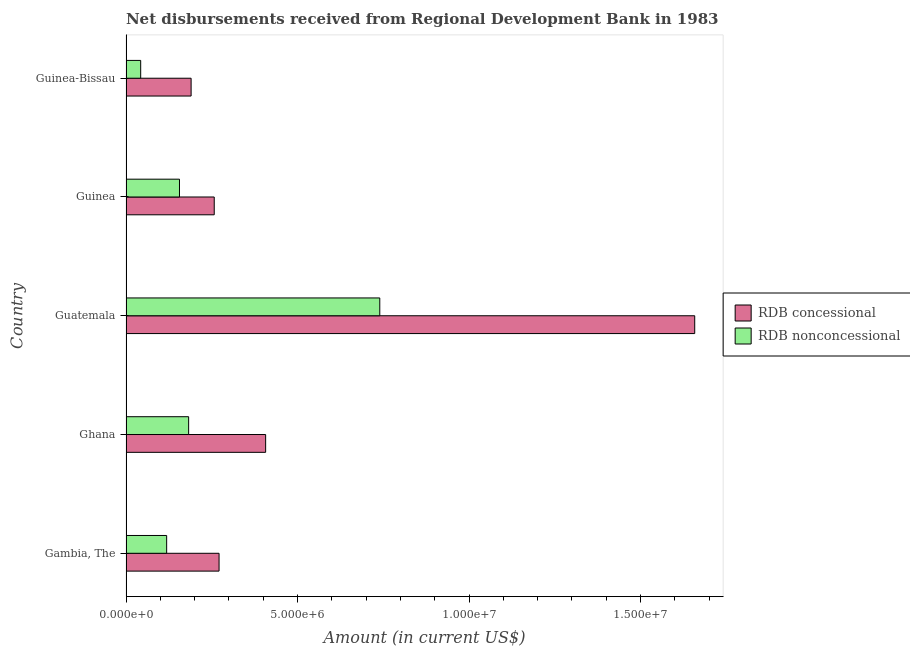How many groups of bars are there?
Your answer should be very brief. 5. What is the label of the 5th group of bars from the top?
Your answer should be very brief. Gambia, The. What is the net non concessional disbursements from rdb in Gambia, The?
Provide a short and direct response. 1.18e+06. Across all countries, what is the maximum net concessional disbursements from rdb?
Offer a very short reply. 1.66e+07. Across all countries, what is the minimum net concessional disbursements from rdb?
Offer a terse response. 1.90e+06. In which country was the net non concessional disbursements from rdb maximum?
Make the answer very short. Guatemala. In which country was the net concessional disbursements from rdb minimum?
Your response must be concise. Guinea-Bissau. What is the total net non concessional disbursements from rdb in the graph?
Offer a terse response. 1.24e+07. What is the difference between the net non concessional disbursements from rdb in Guinea and that in Guinea-Bissau?
Make the answer very short. 1.13e+06. What is the difference between the net non concessional disbursements from rdb in Gambia, The and the net concessional disbursements from rdb in Guinea?
Ensure brevity in your answer.  -1.39e+06. What is the average net non concessional disbursements from rdb per country?
Provide a succinct answer. 2.48e+06. What is the difference between the net non concessional disbursements from rdb and net concessional disbursements from rdb in Guinea?
Your answer should be compact. -1.01e+06. What is the ratio of the net concessional disbursements from rdb in Guatemala to that in Guinea?
Ensure brevity in your answer.  6.45. What is the difference between the highest and the second highest net non concessional disbursements from rdb?
Keep it short and to the point. 5.57e+06. What is the difference between the highest and the lowest net non concessional disbursements from rdb?
Offer a terse response. 6.97e+06. What does the 2nd bar from the top in Guinea represents?
Make the answer very short. RDB concessional. What does the 2nd bar from the bottom in Guinea-Bissau represents?
Your answer should be compact. RDB nonconcessional. How many bars are there?
Offer a very short reply. 10. How many legend labels are there?
Give a very brief answer. 2. What is the title of the graph?
Your answer should be very brief. Net disbursements received from Regional Development Bank in 1983. Does "Males" appear as one of the legend labels in the graph?
Offer a terse response. No. What is the label or title of the Y-axis?
Your response must be concise. Country. What is the Amount (in current US$) of RDB concessional in Gambia, The?
Your response must be concise. 2.71e+06. What is the Amount (in current US$) in RDB nonconcessional in Gambia, The?
Provide a short and direct response. 1.18e+06. What is the Amount (in current US$) of RDB concessional in Ghana?
Your answer should be very brief. 4.07e+06. What is the Amount (in current US$) of RDB nonconcessional in Ghana?
Your answer should be compact. 1.83e+06. What is the Amount (in current US$) of RDB concessional in Guatemala?
Your response must be concise. 1.66e+07. What is the Amount (in current US$) of RDB nonconcessional in Guatemala?
Offer a very short reply. 7.40e+06. What is the Amount (in current US$) of RDB concessional in Guinea?
Your response must be concise. 2.57e+06. What is the Amount (in current US$) in RDB nonconcessional in Guinea?
Give a very brief answer. 1.56e+06. What is the Amount (in current US$) of RDB concessional in Guinea-Bissau?
Your answer should be compact. 1.90e+06. What is the Amount (in current US$) of RDB nonconcessional in Guinea-Bissau?
Make the answer very short. 4.28e+05. Across all countries, what is the maximum Amount (in current US$) in RDB concessional?
Ensure brevity in your answer.  1.66e+07. Across all countries, what is the maximum Amount (in current US$) of RDB nonconcessional?
Keep it short and to the point. 7.40e+06. Across all countries, what is the minimum Amount (in current US$) in RDB concessional?
Provide a short and direct response. 1.90e+06. Across all countries, what is the minimum Amount (in current US$) of RDB nonconcessional?
Provide a succinct answer. 4.28e+05. What is the total Amount (in current US$) of RDB concessional in the graph?
Give a very brief answer. 2.78e+07. What is the total Amount (in current US$) in RDB nonconcessional in the graph?
Ensure brevity in your answer.  1.24e+07. What is the difference between the Amount (in current US$) in RDB concessional in Gambia, The and that in Ghana?
Provide a succinct answer. -1.36e+06. What is the difference between the Amount (in current US$) of RDB nonconcessional in Gambia, The and that in Ghana?
Provide a short and direct response. -6.41e+05. What is the difference between the Amount (in current US$) in RDB concessional in Gambia, The and that in Guatemala?
Provide a succinct answer. -1.39e+07. What is the difference between the Amount (in current US$) in RDB nonconcessional in Gambia, The and that in Guatemala?
Offer a terse response. -6.21e+06. What is the difference between the Amount (in current US$) of RDB concessional in Gambia, The and that in Guinea?
Your answer should be very brief. 1.41e+05. What is the difference between the Amount (in current US$) in RDB nonconcessional in Gambia, The and that in Guinea?
Provide a succinct answer. -3.74e+05. What is the difference between the Amount (in current US$) of RDB concessional in Gambia, The and that in Guinea-Bissau?
Provide a succinct answer. 8.15e+05. What is the difference between the Amount (in current US$) of RDB nonconcessional in Gambia, The and that in Guinea-Bissau?
Your answer should be compact. 7.57e+05. What is the difference between the Amount (in current US$) of RDB concessional in Ghana and that in Guatemala?
Offer a very short reply. -1.25e+07. What is the difference between the Amount (in current US$) in RDB nonconcessional in Ghana and that in Guatemala?
Offer a terse response. -5.57e+06. What is the difference between the Amount (in current US$) in RDB concessional in Ghana and that in Guinea?
Provide a succinct answer. 1.50e+06. What is the difference between the Amount (in current US$) in RDB nonconcessional in Ghana and that in Guinea?
Provide a succinct answer. 2.67e+05. What is the difference between the Amount (in current US$) of RDB concessional in Ghana and that in Guinea-Bissau?
Your answer should be compact. 2.17e+06. What is the difference between the Amount (in current US$) of RDB nonconcessional in Ghana and that in Guinea-Bissau?
Offer a terse response. 1.40e+06. What is the difference between the Amount (in current US$) in RDB concessional in Guatemala and that in Guinea?
Offer a terse response. 1.40e+07. What is the difference between the Amount (in current US$) of RDB nonconcessional in Guatemala and that in Guinea?
Give a very brief answer. 5.84e+06. What is the difference between the Amount (in current US$) of RDB concessional in Guatemala and that in Guinea-Bissau?
Keep it short and to the point. 1.47e+07. What is the difference between the Amount (in current US$) in RDB nonconcessional in Guatemala and that in Guinea-Bissau?
Provide a short and direct response. 6.97e+06. What is the difference between the Amount (in current US$) of RDB concessional in Guinea and that in Guinea-Bissau?
Provide a succinct answer. 6.74e+05. What is the difference between the Amount (in current US$) in RDB nonconcessional in Guinea and that in Guinea-Bissau?
Your response must be concise. 1.13e+06. What is the difference between the Amount (in current US$) of RDB concessional in Gambia, The and the Amount (in current US$) of RDB nonconcessional in Ghana?
Offer a terse response. 8.87e+05. What is the difference between the Amount (in current US$) of RDB concessional in Gambia, The and the Amount (in current US$) of RDB nonconcessional in Guatemala?
Offer a terse response. -4.69e+06. What is the difference between the Amount (in current US$) in RDB concessional in Gambia, The and the Amount (in current US$) in RDB nonconcessional in Guinea?
Your answer should be very brief. 1.15e+06. What is the difference between the Amount (in current US$) in RDB concessional in Gambia, The and the Amount (in current US$) in RDB nonconcessional in Guinea-Bissau?
Keep it short and to the point. 2.28e+06. What is the difference between the Amount (in current US$) of RDB concessional in Ghana and the Amount (in current US$) of RDB nonconcessional in Guatemala?
Ensure brevity in your answer.  -3.33e+06. What is the difference between the Amount (in current US$) in RDB concessional in Ghana and the Amount (in current US$) in RDB nonconcessional in Guinea?
Offer a very short reply. 2.51e+06. What is the difference between the Amount (in current US$) of RDB concessional in Ghana and the Amount (in current US$) of RDB nonconcessional in Guinea-Bissau?
Ensure brevity in your answer.  3.64e+06. What is the difference between the Amount (in current US$) of RDB concessional in Guatemala and the Amount (in current US$) of RDB nonconcessional in Guinea?
Your answer should be very brief. 1.50e+07. What is the difference between the Amount (in current US$) in RDB concessional in Guatemala and the Amount (in current US$) in RDB nonconcessional in Guinea-Bissau?
Keep it short and to the point. 1.62e+07. What is the difference between the Amount (in current US$) of RDB concessional in Guinea and the Amount (in current US$) of RDB nonconcessional in Guinea-Bissau?
Give a very brief answer. 2.14e+06. What is the average Amount (in current US$) of RDB concessional per country?
Ensure brevity in your answer.  5.57e+06. What is the average Amount (in current US$) of RDB nonconcessional per country?
Provide a short and direct response. 2.48e+06. What is the difference between the Amount (in current US$) in RDB concessional and Amount (in current US$) in RDB nonconcessional in Gambia, The?
Your answer should be very brief. 1.53e+06. What is the difference between the Amount (in current US$) of RDB concessional and Amount (in current US$) of RDB nonconcessional in Ghana?
Keep it short and to the point. 2.24e+06. What is the difference between the Amount (in current US$) of RDB concessional and Amount (in current US$) of RDB nonconcessional in Guatemala?
Make the answer very short. 9.18e+06. What is the difference between the Amount (in current US$) in RDB concessional and Amount (in current US$) in RDB nonconcessional in Guinea?
Ensure brevity in your answer.  1.01e+06. What is the difference between the Amount (in current US$) of RDB concessional and Amount (in current US$) of RDB nonconcessional in Guinea-Bissau?
Ensure brevity in your answer.  1.47e+06. What is the ratio of the Amount (in current US$) of RDB concessional in Gambia, The to that in Ghana?
Your response must be concise. 0.67. What is the ratio of the Amount (in current US$) in RDB nonconcessional in Gambia, The to that in Ghana?
Give a very brief answer. 0.65. What is the ratio of the Amount (in current US$) in RDB concessional in Gambia, The to that in Guatemala?
Offer a very short reply. 0.16. What is the ratio of the Amount (in current US$) of RDB nonconcessional in Gambia, The to that in Guatemala?
Provide a short and direct response. 0.16. What is the ratio of the Amount (in current US$) in RDB concessional in Gambia, The to that in Guinea?
Offer a very short reply. 1.05. What is the ratio of the Amount (in current US$) of RDB nonconcessional in Gambia, The to that in Guinea?
Keep it short and to the point. 0.76. What is the ratio of the Amount (in current US$) in RDB concessional in Gambia, The to that in Guinea-Bissau?
Make the answer very short. 1.43. What is the ratio of the Amount (in current US$) in RDB nonconcessional in Gambia, The to that in Guinea-Bissau?
Offer a very short reply. 2.77. What is the ratio of the Amount (in current US$) in RDB concessional in Ghana to that in Guatemala?
Ensure brevity in your answer.  0.25. What is the ratio of the Amount (in current US$) in RDB nonconcessional in Ghana to that in Guatemala?
Offer a terse response. 0.25. What is the ratio of the Amount (in current US$) in RDB concessional in Ghana to that in Guinea?
Offer a very short reply. 1.58. What is the ratio of the Amount (in current US$) in RDB nonconcessional in Ghana to that in Guinea?
Your response must be concise. 1.17. What is the ratio of the Amount (in current US$) in RDB concessional in Ghana to that in Guinea-Bissau?
Offer a very short reply. 2.14. What is the ratio of the Amount (in current US$) in RDB nonconcessional in Ghana to that in Guinea-Bissau?
Your answer should be very brief. 4.27. What is the ratio of the Amount (in current US$) of RDB concessional in Guatemala to that in Guinea?
Offer a very short reply. 6.45. What is the ratio of the Amount (in current US$) in RDB nonconcessional in Guatemala to that in Guinea?
Provide a succinct answer. 4.75. What is the ratio of the Amount (in current US$) in RDB concessional in Guatemala to that in Guinea-Bissau?
Keep it short and to the point. 8.74. What is the ratio of the Amount (in current US$) in RDB nonconcessional in Guatemala to that in Guinea-Bissau?
Provide a succinct answer. 17.29. What is the ratio of the Amount (in current US$) of RDB concessional in Guinea to that in Guinea-Bissau?
Your response must be concise. 1.36. What is the ratio of the Amount (in current US$) of RDB nonconcessional in Guinea to that in Guinea-Bissau?
Offer a terse response. 3.64. What is the difference between the highest and the second highest Amount (in current US$) in RDB concessional?
Ensure brevity in your answer.  1.25e+07. What is the difference between the highest and the second highest Amount (in current US$) of RDB nonconcessional?
Keep it short and to the point. 5.57e+06. What is the difference between the highest and the lowest Amount (in current US$) in RDB concessional?
Give a very brief answer. 1.47e+07. What is the difference between the highest and the lowest Amount (in current US$) in RDB nonconcessional?
Make the answer very short. 6.97e+06. 